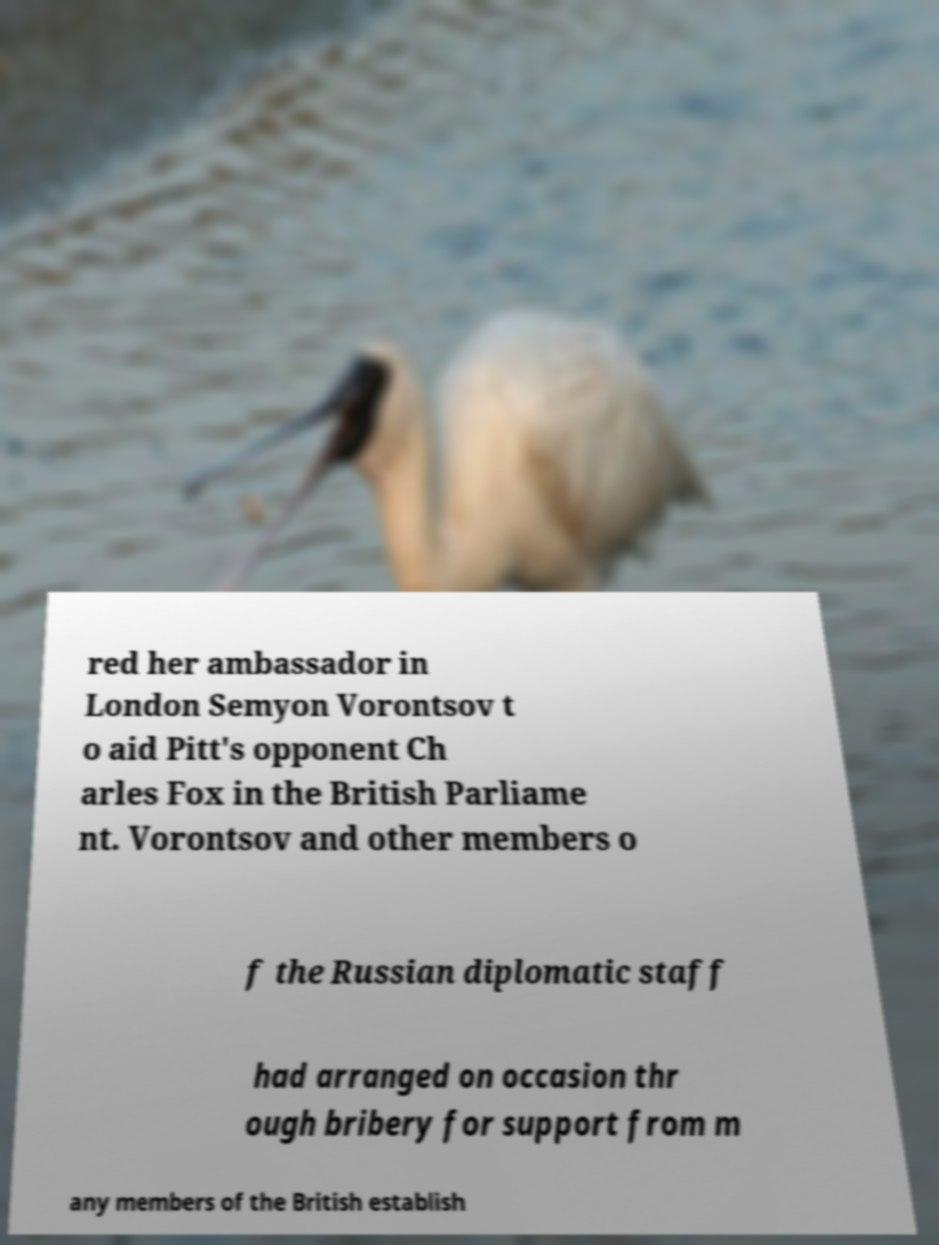What messages or text are displayed in this image? I need them in a readable, typed format. red her ambassador in London Semyon Vorontsov t o aid Pitt's opponent Ch arles Fox in the British Parliame nt. Vorontsov and other members o f the Russian diplomatic staff had arranged on occasion thr ough bribery for support from m any members of the British establish 